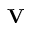<formula> <loc_0><loc_0><loc_500><loc_500>\mathbf V</formula> 